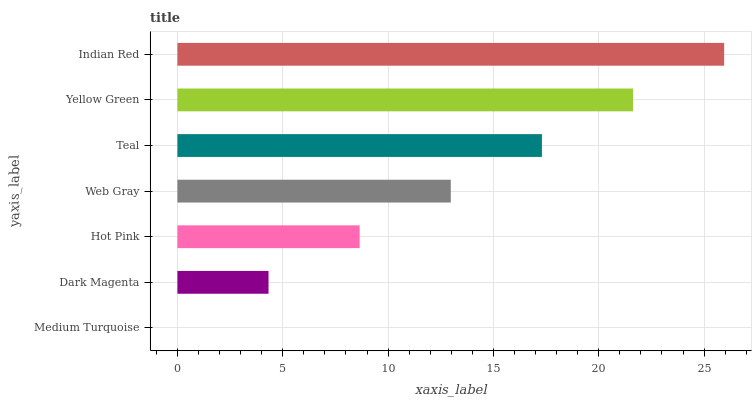Is Medium Turquoise the minimum?
Answer yes or no. Yes. Is Indian Red the maximum?
Answer yes or no. Yes. Is Dark Magenta the minimum?
Answer yes or no. No. Is Dark Magenta the maximum?
Answer yes or no. No. Is Dark Magenta greater than Medium Turquoise?
Answer yes or no. Yes. Is Medium Turquoise less than Dark Magenta?
Answer yes or no. Yes. Is Medium Turquoise greater than Dark Magenta?
Answer yes or no. No. Is Dark Magenta less than Medium Turquoise?
Answer yes or no. No. Is Web Gray the high median?
Answer yes or no. Yes. Is Web Gray the low median?
Answer yes or no. Yes. Is Dark Magenta the high median?
Answer yes or no. No. Is Medium Turquoise the low median?
Answer yes or no. No. 